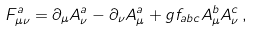<formula> <loc_0><loc_0><loc_500><loc_500>F ^ { a } _ { \mu \nu } = \partial _ { \mu } A ^ { a } _ { \nu } - \partial _ { \nu } A ^ { a } _ { \mu } + g f _ { a b c } A ^ { b } _ { \mu } A ^ { c } _ { \nu } \, ,</formula> 